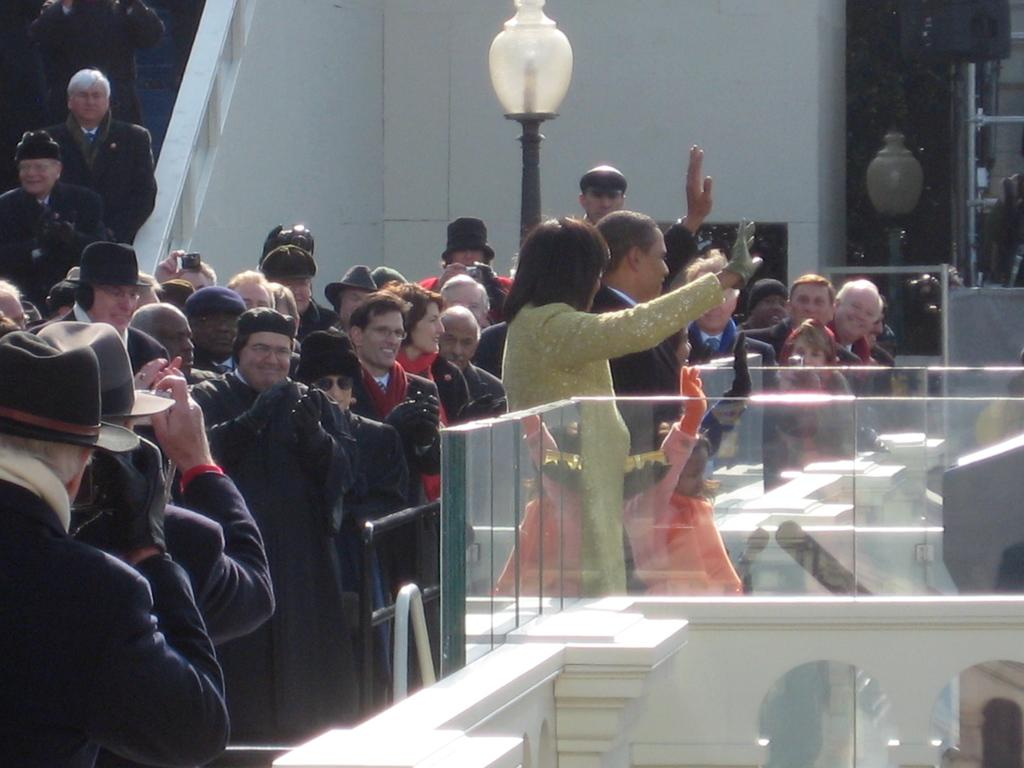What can be seen in the image involving people? There are people standing in the image. What structure is present in the image that provides light? There is a light pole in the image. What type of architectural feature is visible in the image? There is a wall in the image. What allows for a view of the outside in the image? There is a window in the image. What safety feature can be seen in the image? There is a railing with glass in the image. What type of sock is being worn by the person in the image? There is no information about socks or clothing in the image, so it cannot be determined. What unit of measurement is being used to describe the height of the light pole in the image? The facts provided do not mention any specific unit of measurement for the light pole, so it cannot be determined. 